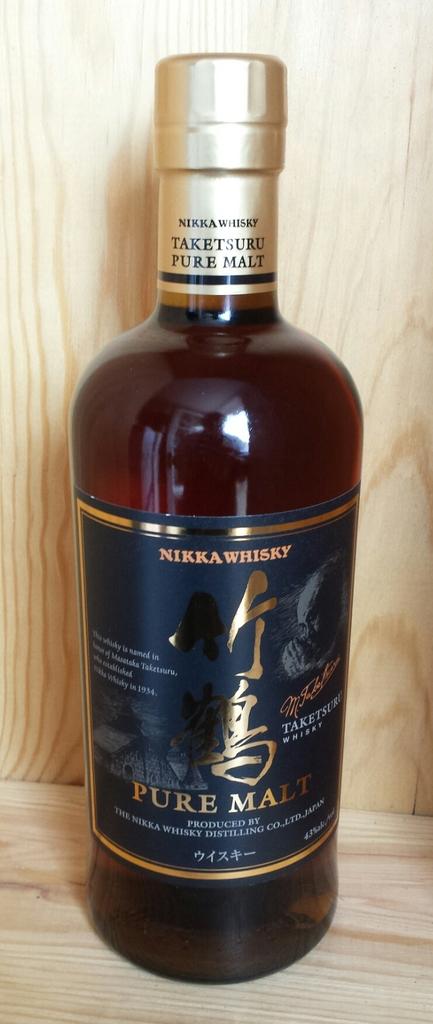Who makes that liquor?
Your response must be concise. Nikka whisky. What kind of liquor is this?
Your answer should be compact. Whisky. 